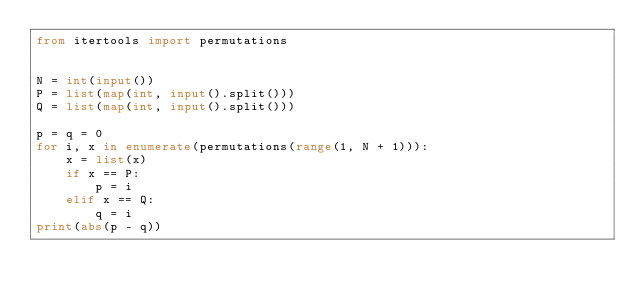Convert code to text. <code><loc_0><loc_0><loc_500><loc_500><_Python_>from itertools import permutations


N = int(input())
P = list(map(int, input().split()))
Q = list(map(int, input().split()))

p = q = 0
for i, x in enumerate(permutations(range(1, N + 1))):
    x = list(x)
    if x == P:
        p = i
    elif x == Q:
        q = i
print(abs(p - q))
</code> 